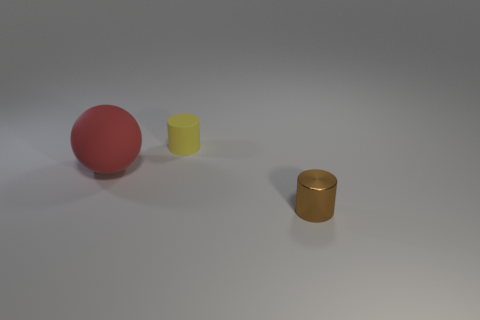Add 1 tiny purple cylinders. How many objects exist? 4 Subtract all balls. How many objects are left? 2 Add 2 small yellow matte cylinders. How many small yellow matte cylinders exist? 3 Subtract 0 gray balls. How many objects are left? 3 Subtract all tiny brown cylinders. Subtract all metal cylinders. How many objects are left? 1 Add 2 spheres. How many spheres are left? 3 